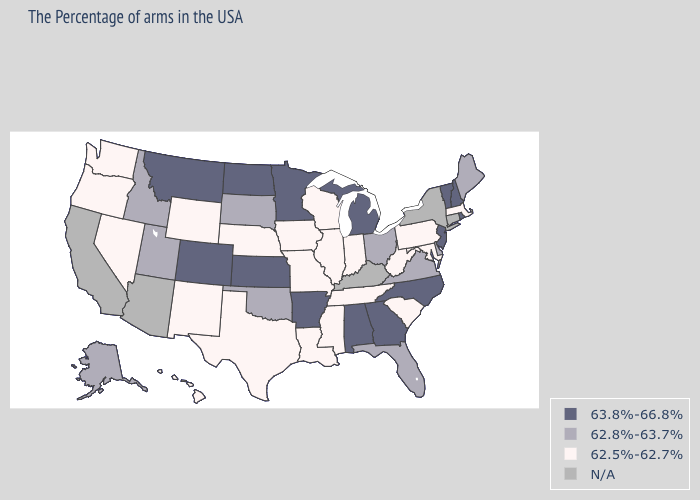Name the states that have a value in the range 63.8%-66.8%?
Write a very short answer. Rhode Island, New Hampshire, Vermont, New Jersey, North Carolina, Georgia, Michigan, Alabama, Arkansas, Minnesota, Kansas, North Dakota, Colorado, Montana. What is the highest value in states that border Wyoming?
Quick response, please. 63.8%-66.8%. What is the value of Virginia?
Give a very brief answer. 62.8%-63.7%. What is the highest value in the West ?
Keep it brief. 63.8%-66.8%. Which states have the lowest value in the USA?
Write a very short answer. Massachusetts, Maryland, Pennsylvania, South Carolina, West Virginia, Indiana, Tennessee, Wisconsin, Illinois, Mississippi, Louisiana, Missouri, Iowa, Nebraska, Texas, Wyoming, New Mexico, Nevada, Washington, Oregon, Hawaii. What is the highest value in states that border Michigan?
Answer briefly. 62.8%-63.7%. Which states have the highest value in the USA?
Quick response, please. Rhode Island, New Hampshire, Vermont, New Jersey, North Carolina, Georgia, Michigan, Alabama, Arkansas, Minnesota, Kansas, North Dakota, Colorado, Montana. What is the value of Vermont?
Write a very short answer. 63.8%-66.8%. Name the states that have a value in the range N/A?
Quick response, please. Connecticut, New York, Kentucky, Arizona, California. Name the states that have a value in the range 62.8%-63.7%?
Keep it brief. Maine, Delaware, Virginia, Ohio, Florida, Oklahoma, South Dakota, Utah, Idaho, Alaska. Among the states that border California , which have the highest value?
Concise answer only. Nevada, Oregon. Does the first symbol in the legend represent the smallest category?
Answer briefly. No. What is the value of Oklahoma?
Write a very short answer. 62.8%-63.7%. What is the value of New Hampshire?
Short answer required. 63.8%-66.8%. 